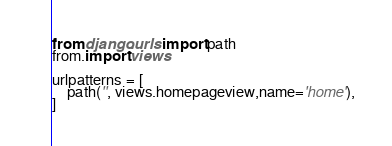<code> <loc_0><loc_0><loc_500><loc_500><_Python_>

from django.urls import path
from.import views

urlpatterns = [
    path('', views.homepageview,name='home'),
]</code> 